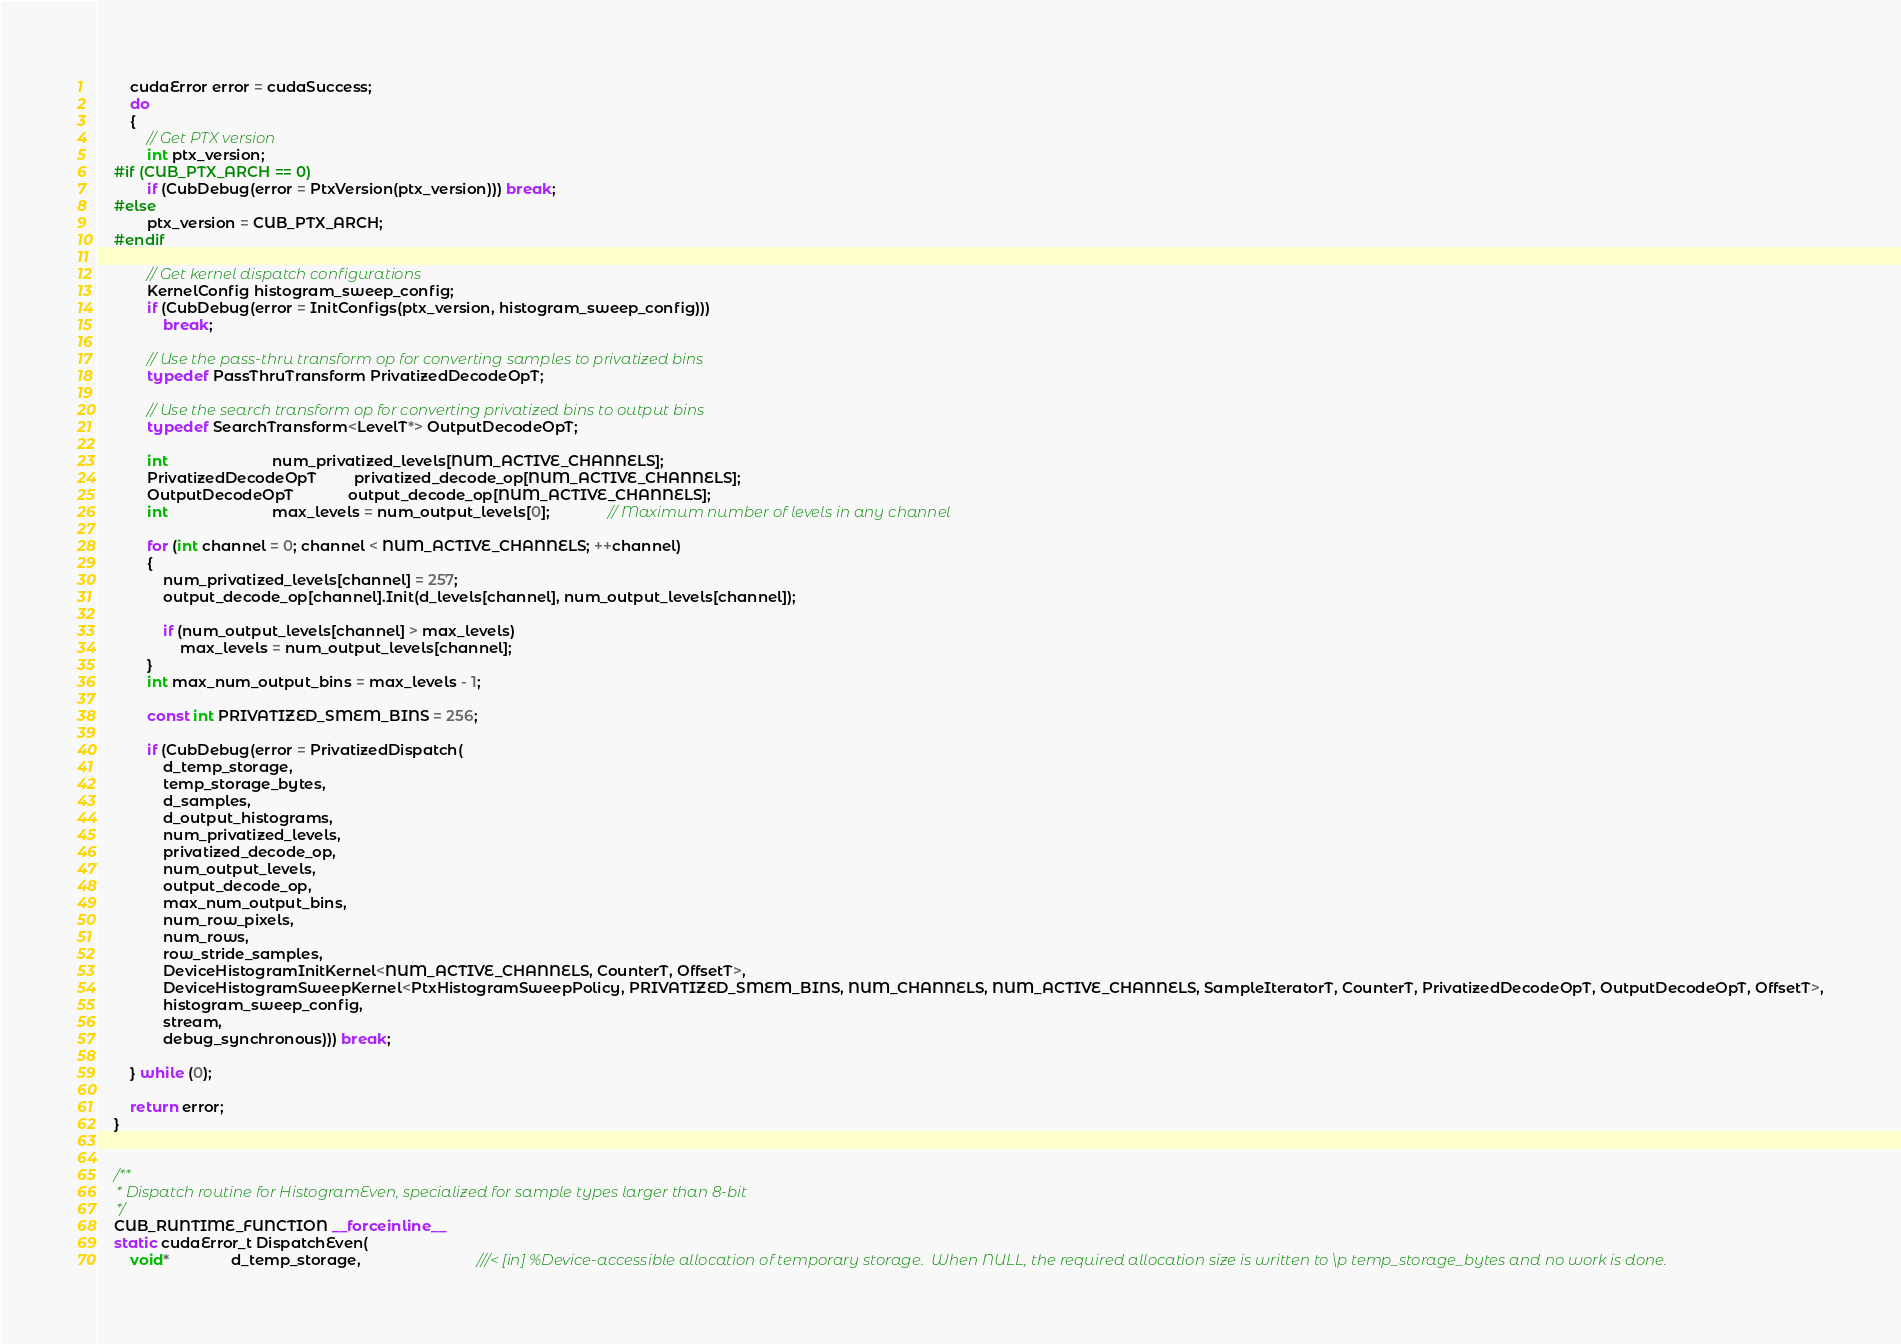<code> <loc_0><loc_0><loc_500><loc_500><_Cuda_>        cudaError error = cudaSuccess;
        do
        {
            // Get PTX version
            int ptx_version;
    #if (CUB_PTX_ARCH == 0)
            if (CubDebug(error = PtxVersion(ptx_version))) break;
    #else
            ptx_version = CUB_PTX_ARCH;
    #endif

            // Get kernel dispatch configurations
            KernelConfig histogram_sweep_config;
            if (CubDebug(error = InitConfigs(ptx_version, histogram_sweep_config)))
                break;

            // Use the pass-thru transform op for converting samples to privatized bins
            typedef PassThruTransform PrivatizedDecodeOpT;

            // Use the search transform op for converting privatized bins to output bins
            typedef SearchTransform<LevelT*> OutputDecodeOpT;

            int                         num_privatized_levels[NUM_ACTIVE_CHANNELS];
            PrivatizedDecodeOpT         privatized_decode_op[NUM_ACTIVE_CHANNELS];
            OutputDecodeOpT             output_decode_op[NUM_ACTIVE_CHANNELS];
            int                         max_levels = num_output_levels[0];              // Maximum number of levels in any channel

            for (int channel = 0; channel < NUM_ACTIVE_CHANNELS; ++channel)
            {
                num_privatized_levels[channel] = 257;
                output_decode_op[channel].Init(d_levels[channel], num_output_levels[channel]);

                if (num_output_levels[channel] > max_levels)
                    max_levels = num_output_levels[channel];
            }
            int max_num_output_bins = max_levels - 1;

            const int PRIVATIZED_SMEM_BINS = 256;

            if (CubDebug(error = PrivatizedDispatch(
                d_temp_storage,
                temp_storage_bytes,
                d_samples,
                d_output_histograms,
                num_privatized_levels,
                privatized_decode_op,
                num_output_levels,
                output_decode_op,
                max_num_output_bins,
                num_row_pixels,
                num_rows,
                row_stride_samples,
                DeviceHistogramInitKernel<NUM_ACTIVE_CHANNELS, CounterT, OffsetT>,
                DeviceHistogramSweepKernel<PtxHistogramSweepPolicy, PRIVATIZED_SMEM_BINS, NUM_CHANNELS, NUM_ACTIVE_CHANNELS, SampleIteratorT, CounterT, PrivatizedDecodeOpT, OutputDecodeOpT, OffsetT>,
                histogram_sweep_config,
                stream,
                debug_synchronous))) break;

        } while (0);

        return error;
    }


    /**
     * Dispatch routine for HistogramEven, specialized for sample types larger than 8-bit
     */
    CUB_RUNTIME_FUNCTION __forceinline__
    static cudaError_t DispatchEven(
        void*               d_temp_storage,                            ///< [in] %Device-accessible allocation of temporary storage.  When NULL, the required allocation size is written to \p temp_storage_bytes and no work is done.</code> 